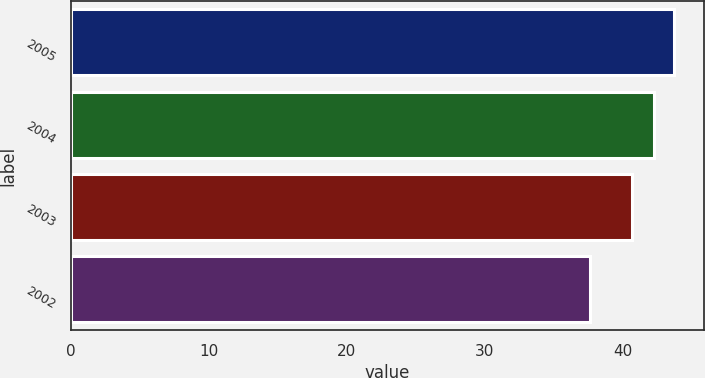<chart> <loc_0><loc_0><loc_500><loc_500><bar_chart><fcel>2005<fcel>2004<fcel>2003<fcel>2002<nl><fcel>43.67<fcel>42.22<fcel>40.68<fcel>37.62<nl></chart> 